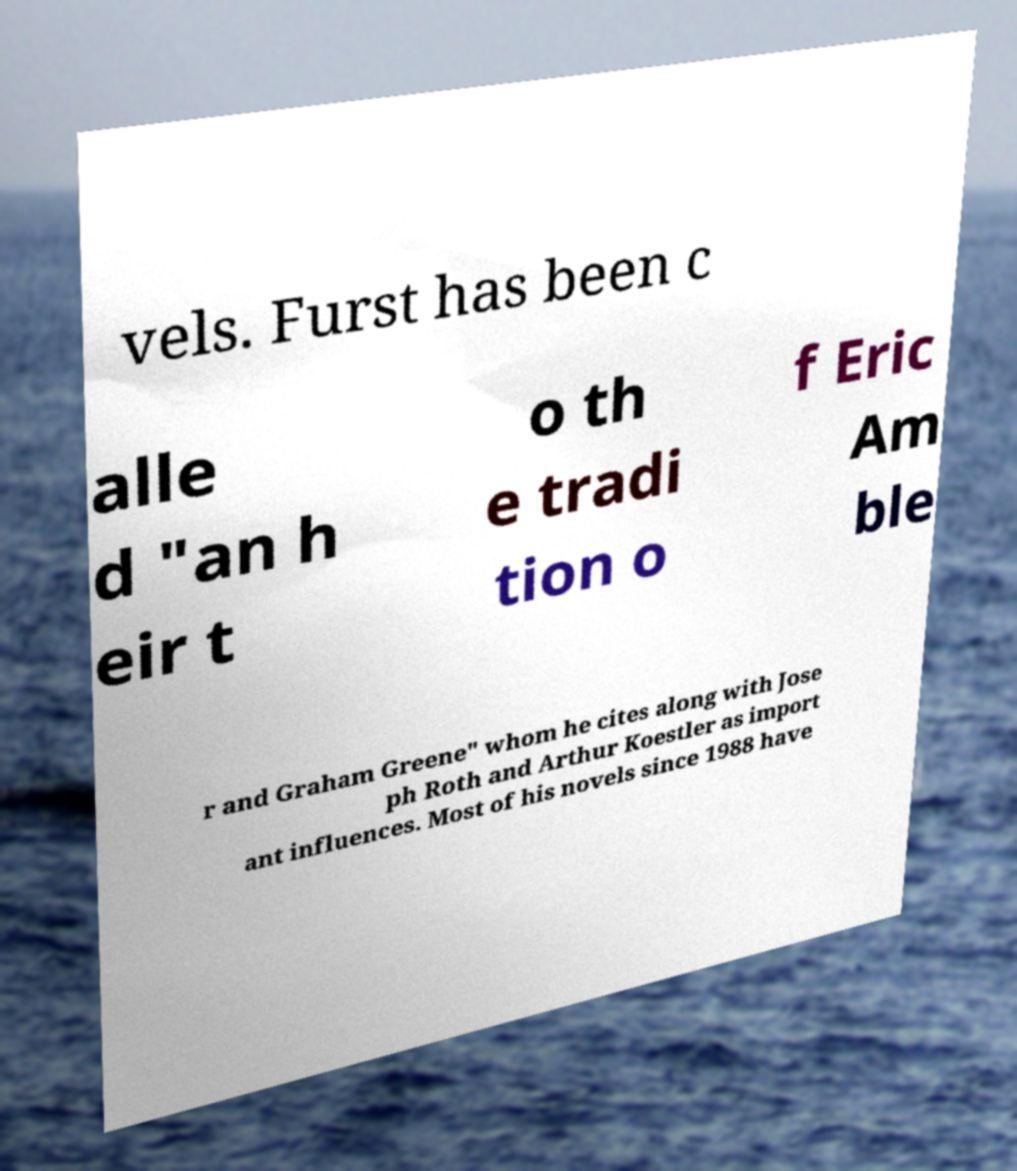There's text embedded in this image that I need extracted. Can you transcribe it verbatim? vels. Furst has been c alle d "an h eir t o th e tradi tion o f Eric Am ble r and Graham Greene" whom he cites along with Jose ph Roth and Arthur Koestler as import ant influences. Most of his novels since 1988 have 